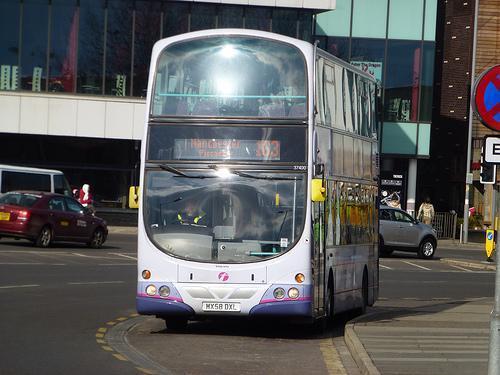How many levels does the bus have?
Give a very brief answer. 2. 